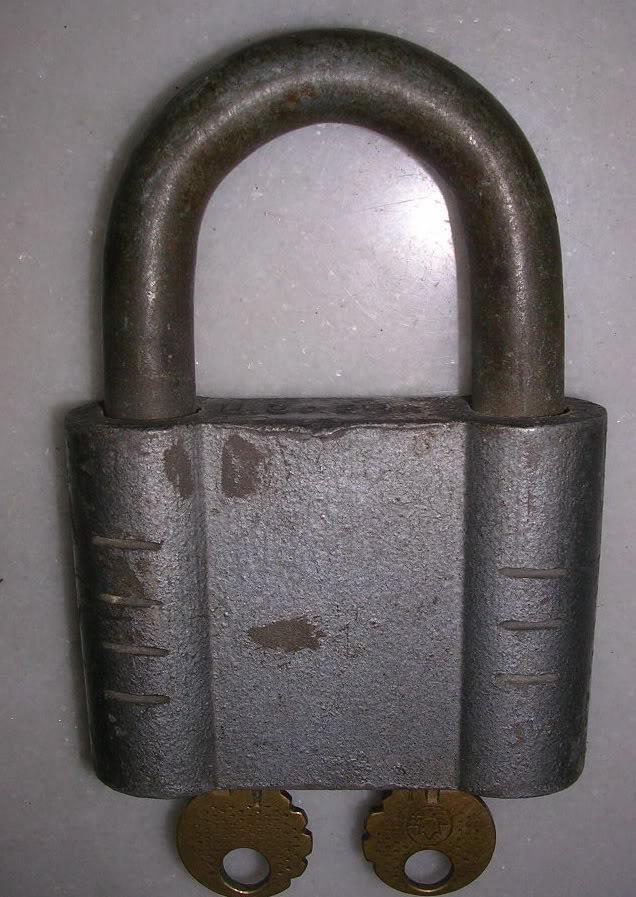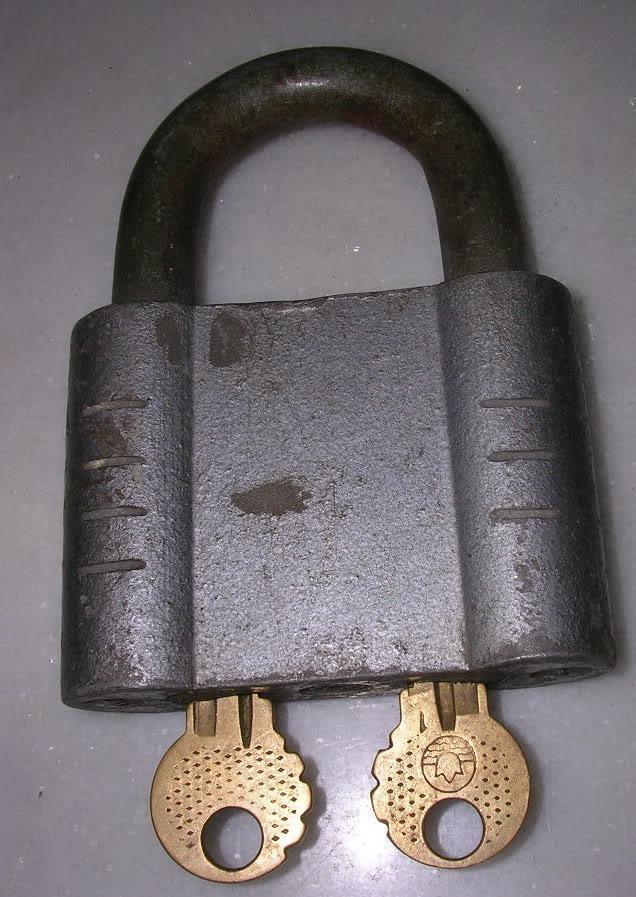The first image is the image on the left, the second image is the image on the right. For the images shown, is this caption "there are locks with the keys inserted in the bottom" true? Answer yes or no. Yes. The first image is the image on the left, the second image is the image on the right. Considering the images on both sides, is "There are no less than two keys inserted into padlocks" valid? Answer yes or no. Yes. 